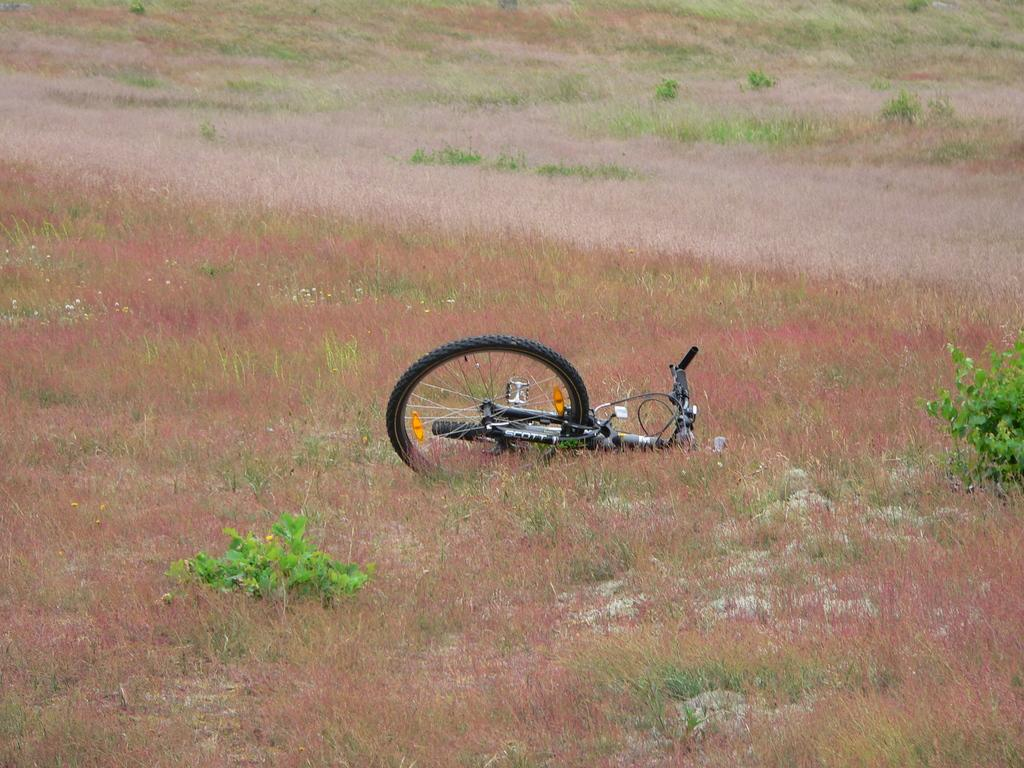What is the main object in the image? There is a bicycle in the image. How is the bicycle positioned in the image? The bicycle is lying on the ground. What type of terrain is visible in the image? There is grass in the image. Are there any other plants visible besides the grass? Yes, there are small plants visible in the image. What type of nut is the queen holding in the image? There is no queen or nut present in the image; it features a bicycle lying on the ground with grass and small plants visible. 